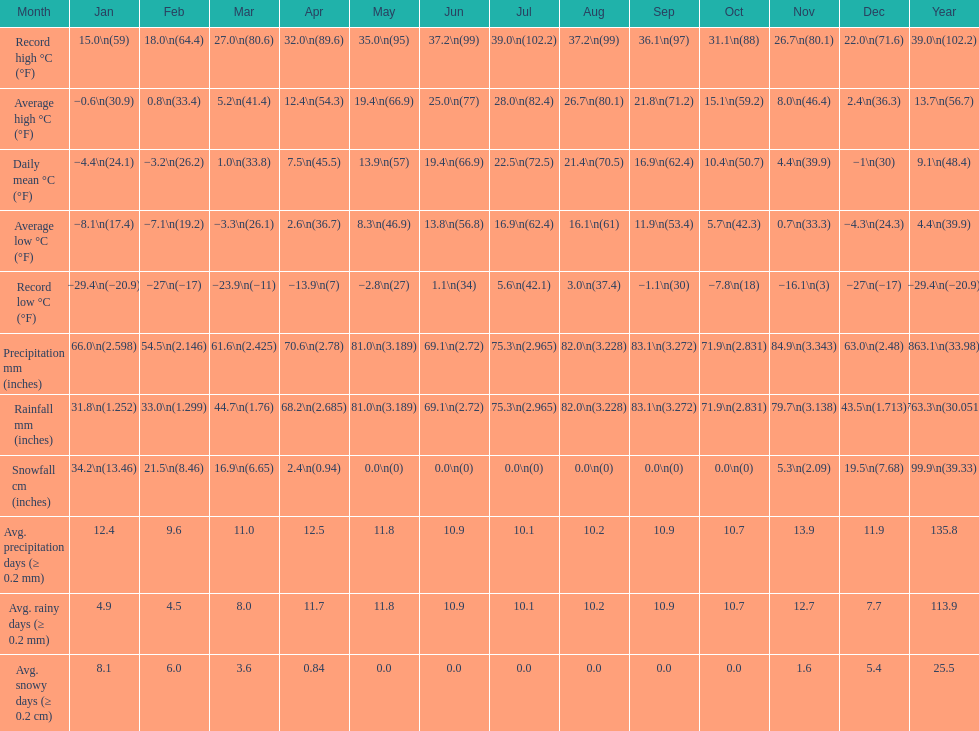1? September. I'm looking to parse the entire table for insights. Could you assist me with that? {'header': ['Month', 'Jan', 'Feb', 'Mar', 'Apr', 'May', 'Jun', 'Jul', 'Aug', 'Sep', 'Oct', 'Nov', 'Dec', 'Year'], 'rows': [['Record high °C (°F)', '15.0\\n(59)', '18.0\\n(64.4)', '27.0\\n(80.6)', '32.0\\n(89.6)', '35.0\\n(95)', '37.2\\n(99)', '39.0\\n(102.2)', '37.2\\n(99)', '36.1\\n(97)', '31.1\\n(88)', '26.7\\n(80.1)', '22.0\\n(71.6)', '39.0\\n(102.2)'], ['Average high °C (°F)', '−0.6\\n(30.9)', '0.8\\n(33.4)', '5.2\\n(41.4)', '12.4\\n(54.3)', '19.4\\n(66.9)', '25.0\\n(77)', '28.0\\n(82.4)', '26.7\\n(80.1)', '21.8\\n(71.2)', '15.1\\n(59.2)', '8.0\\n(46.4)', '2.4\\n(36.3)', '13.7\\n(56.7)'], ['Daily mean °C (°F)', '−4.4\\n(24.1)', '−3.2\\n(26.2)', '1.0\\n(33.8)', '7.5\\n(45.5)', '13.9\\n(57)', '19.4\\n(66.9)', '22.5\\n(72.5)', '21.4\\n(70.5)', '16.9\\n(62.4)', '10.4\\n(50.7)', '4.4\\n(39.9)', '−1\\n(30)', '9.1\\n(48.4)'], ['Average low °C (°F)', '−8.1\\n(17.4)', '−7.1\\n(19.2)', '−3.3\\n(26.1)', '2.6\\n(36.7)', '8.3\\n(46.9)', '13.8\\n(56.8)', '16.9\\n(62.4)', '16.1\\n(61)', '11.9\\n(53.4)', '5.7\\n(42.3)', '0.7\\n(33.3)', '−4.3\\n(24.3)', '4.4\\n(39.9)'], ['Record low °C (°F)', '−29.4\\n(−20.9)', '−27\\n(−17)', '−23.9\\n(−11)', '−13.9\\n(7)', '−2.8\\n(27)', '1.1\\n(34)', '5.6\\n(42.1)', '3.0\\n(37.4)', '−1.1\\n(30)', '−7.8\\n(18)', '−16.1\\n(3)', '−27\\n(−17)', '−29.4\\n(−20.9)'], ['Precipitation mm (inches)', '66.0\\n(2.598)', '54.5\\n(2.146)', '61.6\\n(2.425)', '70.6\\n(2.78)', '81.0\\n(3.189)', '69.1\\n(2.72)', '75.3\\n(2.965)', '82.0\\n(3.228)', '83.1\\n(3.272)', '71.9\\n(2.831)', '84.9\\n(3.343)', '63.0\\n(2.48)', '863.1\\n(33.98)'], ['Rainfall mm (inches)', '31.8\\n(1.252)', '33.0\\n(1.299)', '44.7\\n(1.76)', '68.2\\n(2.685)', '81.0\\n(3.189)', '69.1\\n(2.72)', '75.3\\n(2.965)', '82.0\\n(3.228)', '83.1\\n(3.272)', '71.9\\n(2.831)', '79.7\\n(3.138)', '43.5\\n(1.713)', '763.3\\n(30.051)'], ['Snowfall cm (inches)', '34.2\\n(13.46)', '21.5\\n(8.46)', '16.9\\n(6.65)', '2.4\\n(0.94)', '0.0\\n(0)', '0.0\\n(0)', '0.0\\n(0)', '0.0\\n(0)', '0.0\\n(0)', '0.0\\n(0)', '5.3\\n(2.09)', '19.5\\n(7.68)', '99.9\\n(39.33)'], ['Avg. precipitation days (≥ 0.2 mm)', '12.4', '9.6', '11.0', '12.5', '11.8', '10.9', '10.1', '10.2', '10.9', '10.7', '13.9', '11.9', '135.8'], ['Avg. rainy days (≥ 0.2 mm)', '4.9', '4.5', '8.0', '11.7', '11.8', '10.9', '10.1', '10.2', '10.9', '10.7', '12.7', '7.7', '113.9'], ['Avg. snowy days (≥ 0.2 cm)', '8.1', '6.0', '3.6', '0.84', '0.0', '0.0', '0.0', '0.0', '0.0', '0.0', '1.6', '5.4', '25.5']]} 